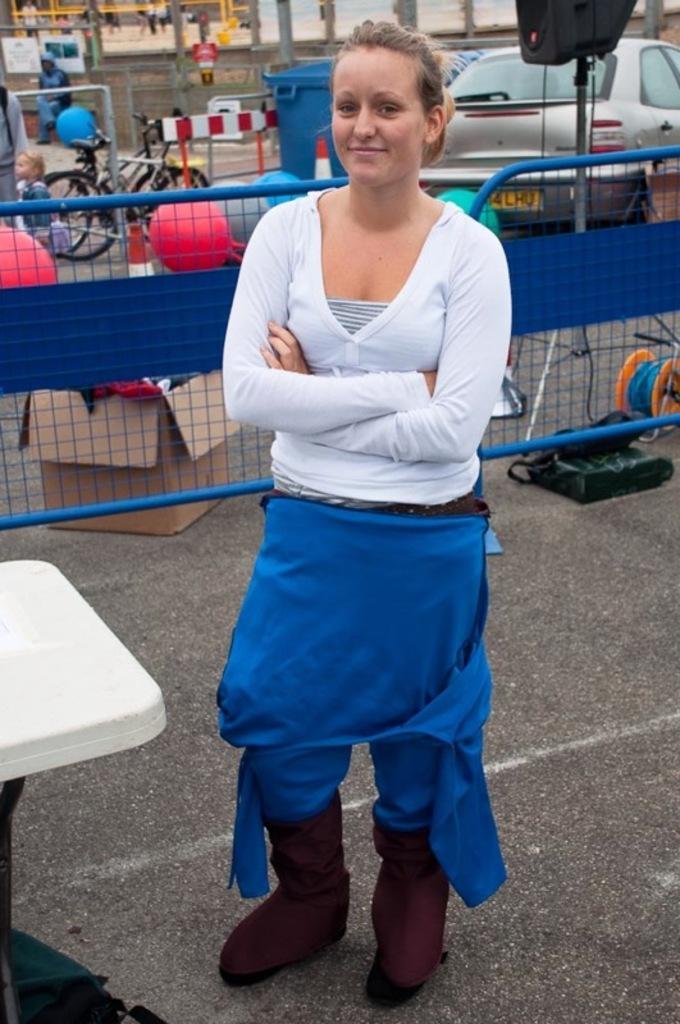In one or two sentences, can you explain what this image depicts? The women wearing white shirt is standing and there is a blue barrier,car,bicycles behind her. 